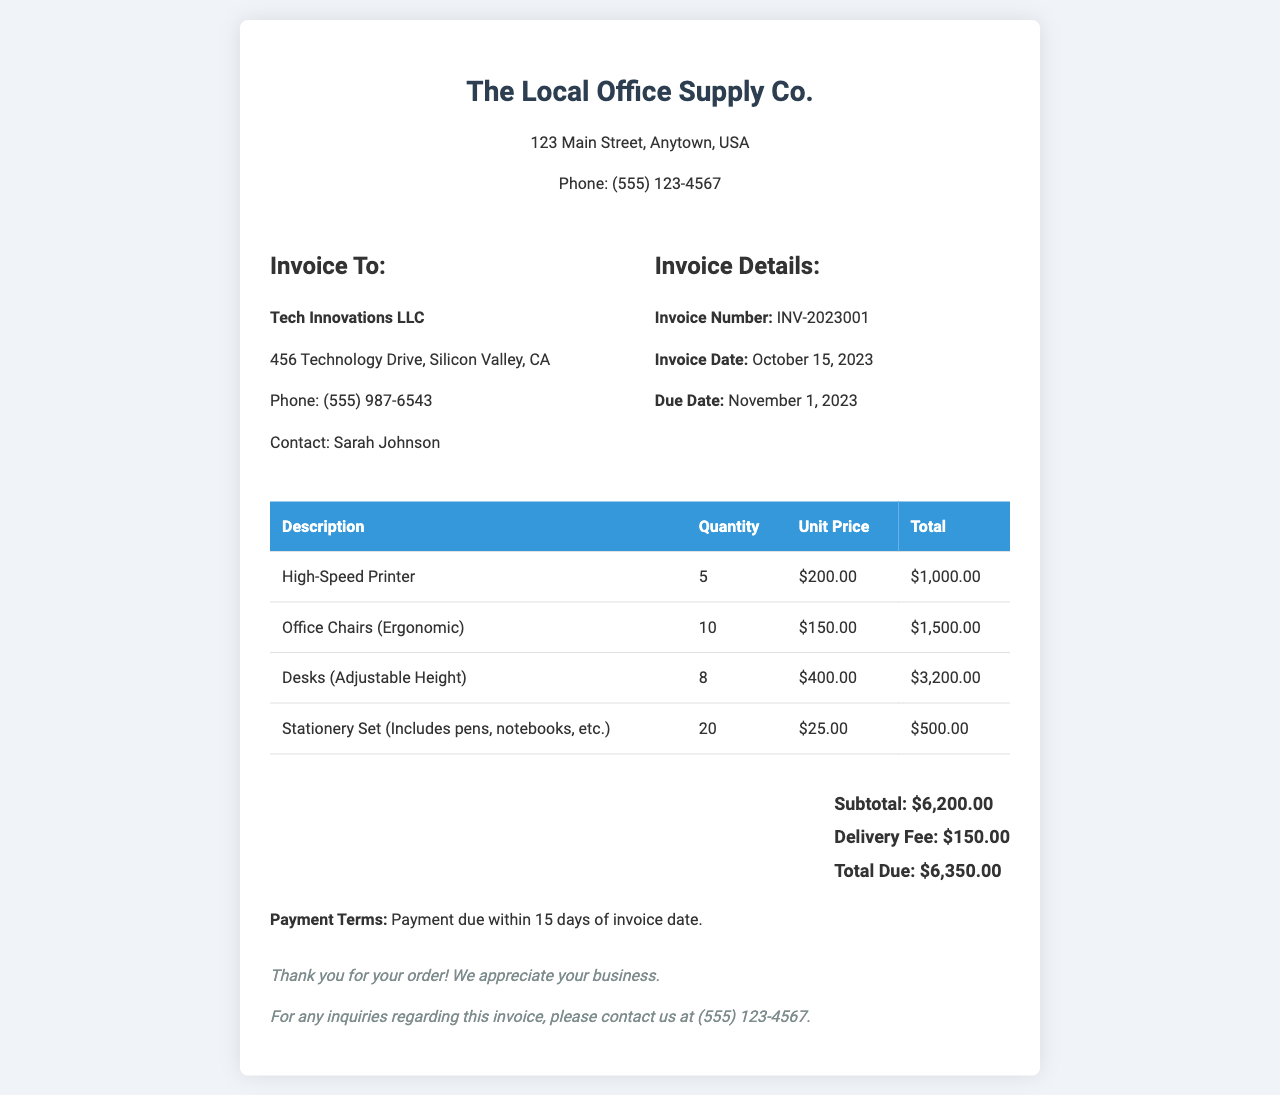What is the invoice number? The invoice number is clearly listed under the invoice details section in the document.
Answer: INV-2023001 What is the due date for payment? The due date is specified in the invoice details section, indicating when payment should be made.
Answer: November 1, 2023 How many high-speed printers are ordered? The quantity of high-speed printers can be found in the itemized list of products in the table.
Answer: 5 What is the subtotal before delivery fees? The subtotal represents the total amount for all items before any additional fees are added, which is itemized in the total section.
Answer: $6,200.00 What is the total amount due? The total amount due is located at the bottom of the invoice, representing the final payment required.
Answer: $6,350.00 Who is the contact person for the invoice? The contact person is indicated in the invoice recipient section as responsible for any communications regarding the invoice.
Answer: Sarah Johnson What is the delivery fee? The delivery fee is mentioned along with the subtotal in the total section of the document, detailing the charge for delivery.
Answer: $150.00 What kind of chairs are being ordered? The type of chairs is explicitly written in the itemized product description within the table.
Answer: Ergonomic What are the payment terms stated in the invoice? The payment terms section provides specific information on when the payment should be made in relation to the invoice date.
Answer: Payment due within 15 days of invoice date 